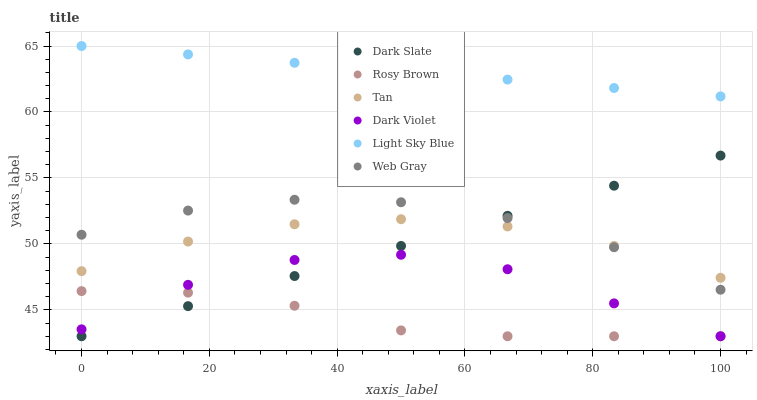Does Rosy Brown have the minimum area under the curve?
Answer yes or no. Yes. Does Light Sky Blue have the maximum area under the curve?
Answer yes or no. Yes. Does Dark Violet have the minimum area under the curve?
Answer yes or no. No. Does Dark Violet have the maximum area under the curve?
Answer yes or no. No. Is Dark Slate the smoothest?
Answer yes or no. Yes. Is Dark Violet the roughest?
Answer yes or no. Yes. Is Rosy Brown the smoothest?
Answer yes or no. No. Is Rosy Brown the roughest?
Answer yes or no. No. Does Rosy Brown have the lowest value?
Answer yes or no. Yes. Does Light Sky Blue have the lowest value?
Answer yes or no. No. Does Light Sky Blue have the highest value?
Answer yes or no. Yes. Does Dark Violet have the highest value?
Answer yes or no. No. Is Dark Violet less than Web Gray?
Answer yes or no. Yes. Is Web Gray greater than Rosy Brown?
Answer yes or no. Yes. Does Dark Slate intersect Web Gray?
Answer yes or no. Yes. Is Dark Slate less than Web Gray?
Answer yes or no. No. Is Dark Slate greater than Web Gray?
Answer yes or no. No. Does Dark Violet intersect Web Gray?
Answer yes or no. No. 